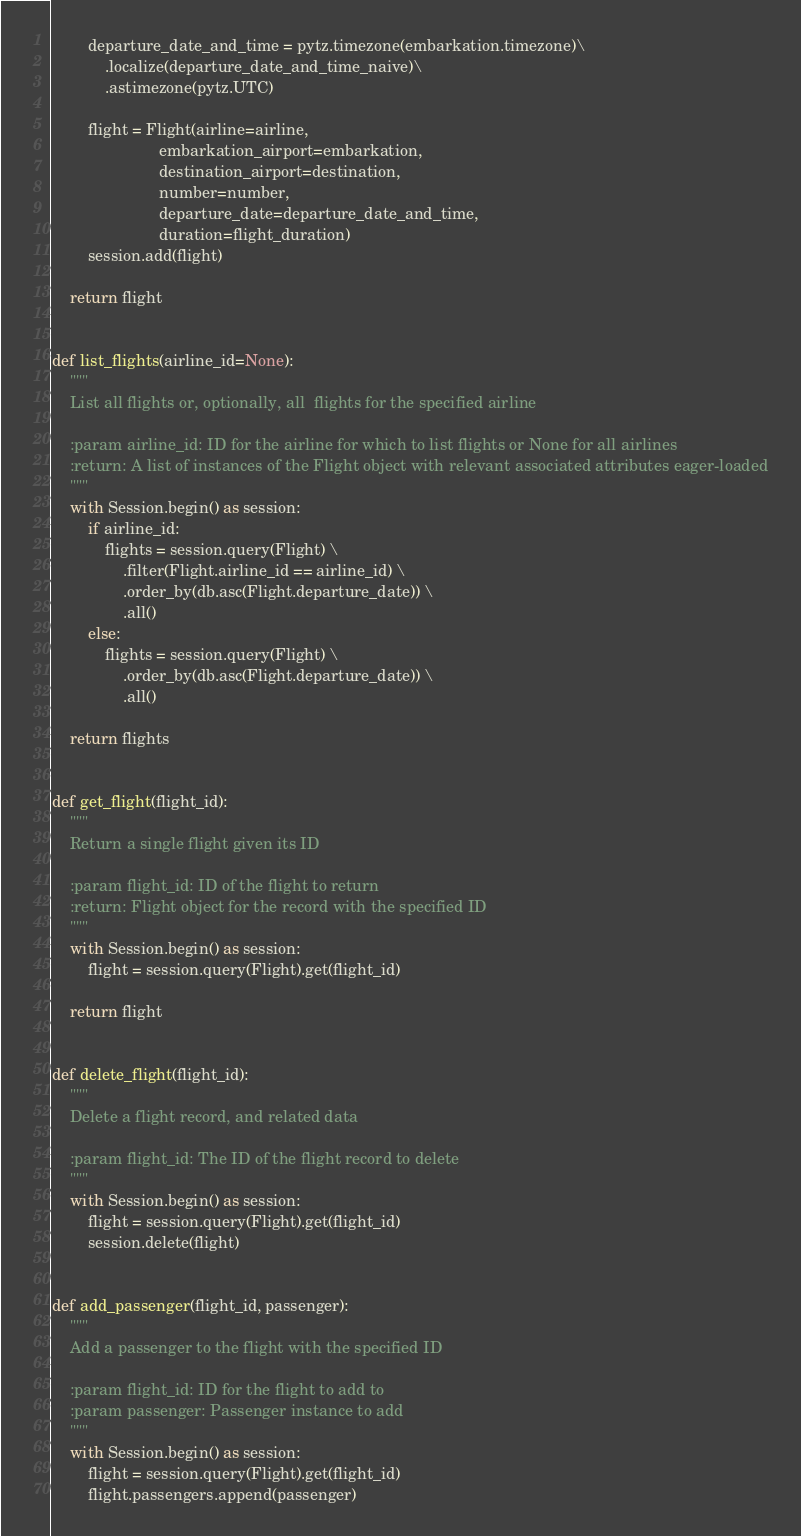<code> <loc_0><loc_0><loc_500><loc_500><_Python_>        departure_date_and_time = pytz.timezone(embarkation.timezone)\
            .localize(departure_date_and_time_naive)\
            .astimezone(pytz.UTC)

        flight = Flight(airline=airline,
                        embarkation_airport=embarkation,
                        destination_airport=destination,
                        number=number,
                        departure_date=departure_date_and_time,
                        duration=flight_duration)
        session.add(flight)

    return flight


def list_flights(airline_id=None):
    """
    List all flights or, optionally, all  flights for the specified airline

    :param airline_id: ID for the airline for which to list flights or None for all airlines
    :return: A list of instances of the Flight object with relevant associated attributes eager-loaded
    """
    with Session.begin() as session:
        if airline_id:
            flights = session.query(Flight) \
                .filter(Flight.airline_id == airline_id) \
                .order_by(db.asc(Flight.departure_date)) \
                .all()
        else:
            flights = session.query(Flight) \
                .order_by(db.asc(Flight.departure_date)) \
                .all()

    return flights


def get_flight(flight_id):
    """
    Return a single flight given its ID

    :param flight_id: ID of the flight to return
    :return: Flight object for the record with the specified ID
    """
    with Session.begin() as session:
        flight = session.query(Flight).get(flight_id)

    return flight


def delete_flight(flight_id):
    """
    Delete a flight record, and related data

    :param flight_id: The ID of the flight record to delete
    """
    with Session.begin() as session:
        flight = session.query(Flight).get(flight_id)
        session.delete(flight)


def add_passenger(flight_id, passenger):
    """
    Add a passenger to the flight with the specified ID

    :param flight_id: ID for the flight to add to
    :param passenger: Passenger instance to add
    """
    with Session.begin() as session:
        flight = session.query(Flight).get(flight_id)
        flight.passengers.append(passenger)
</code> 